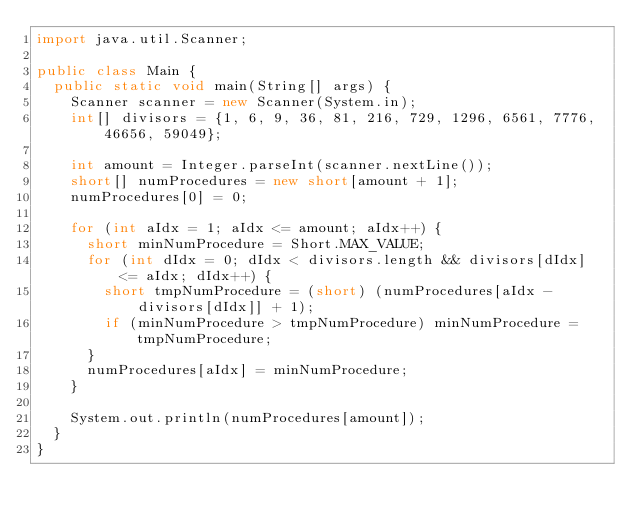<code> <loc_0><loc_0><loc_500><loc_500><_Java_>import java.util.Scanner;

public class Main {
	public static void main(String[] args) {
		Scanner scanner = new Scanner(System.in);
		int[] divisors = {1, 6, 9, 36, 81, 216, 729, 1296, 6561, 7776, 46656, 59049};

		int amount = Integer.parseInt(scanner.nextLine());
		short[] numProcedures = new short[amount + 1];
		numProcedures[0] = 0;

		for (int aIdx = 1; aIdx <= amount; aIdx++) {
			short minNumProcedure = Short.MAX_VALUE;
			for (int dIdx = 0; dIdx < divisors.length && divisors[dIdx] <= aIdx; dIdx++) {
				short tmpNumProcedure = (short) (numProcedures[aIdx - divisors[dIdx]] + 1);
				if (minNumProcedure > tmpNumProcedure) minNumProcedure = tmpNumProcedure;
			}
			numProcedures[aIdx] = minNumProcedure;
		}

		System.out.println(numProcedures[amount]);
	}
}
</code> 